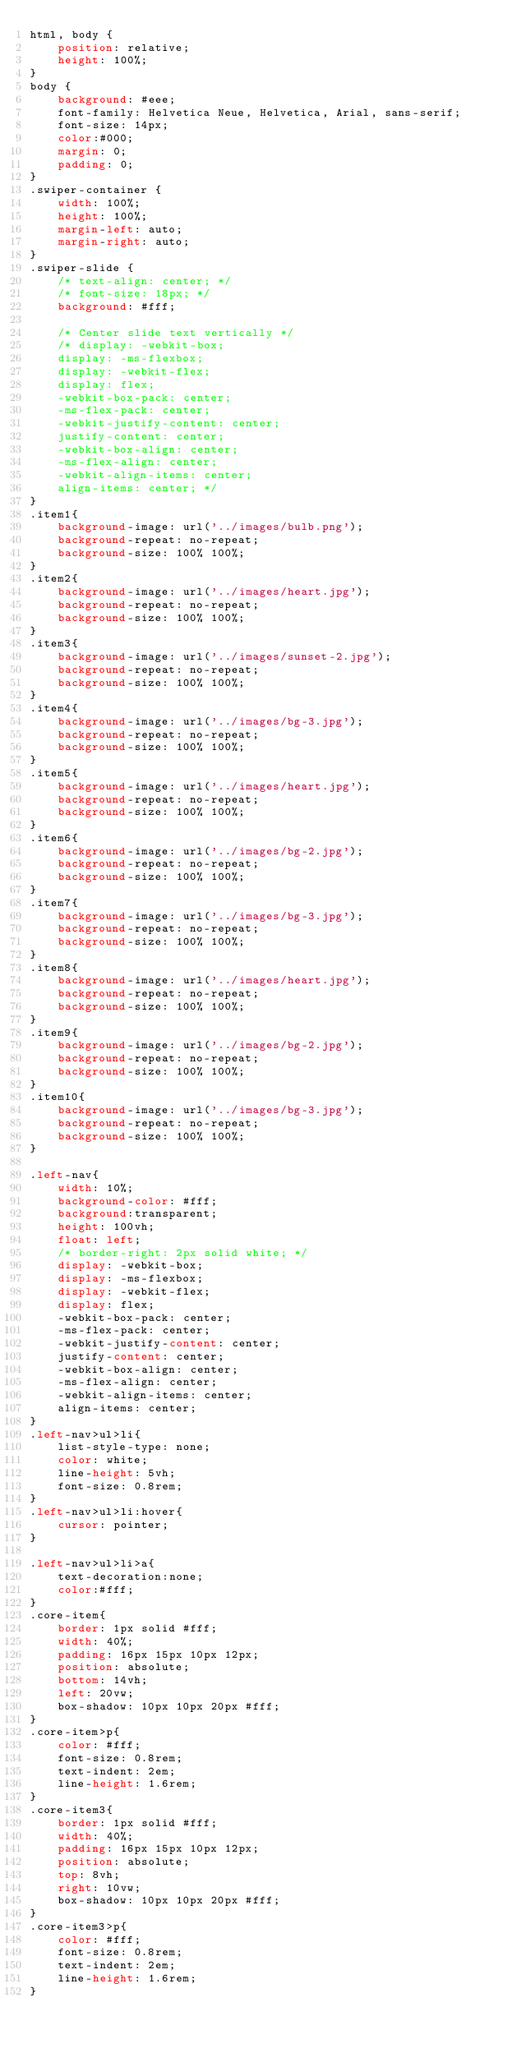Convert code to text. <code><loc_0><loc_0><loc_500><loc_500><_CSS_>html, body {
    position: relative;
    height: 100%;
}
body {
    background: #eee;
    font-family: Helvetica Neue, Helvetica, Arial, sans-serif;
    font-size: 14px;
    color:#000;
    margin: 0;
    padding: 0;
}
.swiper-container {
    width: 100%;
    height: 100%;
    margin-left: auto;
    margin-right: auto;
}
.swiper-slide {
    /* text-align: center; */
    /* font-size: 18px; */
    background: #fff;

    /* Center slide text vertically */
    /* display: -webkit-box;
    display: -ms-flexbox;
    display: -webkit-flex;
    display: flex;
    -webkit-box-pack: center;
    -ms-flex-pack: center;
    -webkit-justify-content: center;
    justify-content: center;
    -webkit-box-align: center;
    -ms-flex-align: center;
    -webkit-align-items: center;
    align-items: center; */
}
.item1{
    background-image: url('../images/bulb.png');
    background-repeat: no-repeat;
    background-size: 100% 100%;
}
.item2{
    background-image: url('../images/heart.jpg');
    background-repeat: no-repeat;
    background-size: 100% 100%;
}
.item3{
    background-image: url('../images/sunset-2.jpg');
    background-repeat: no-repeat;
    background-size: 100% 100%;
}
.item4{
    background-image: url('../images/bg-3.jpg');
    background-repeat: no-repeat;
    background-size: 100% 100%;
}
.item5{
    background-image: url('../images/heart.jpg');
    background-repeat: no-repeat;
    background-size: 100% 100%;
}
.item6{
    background-image: url('../images/bg-2.jpg');
    background-repeat: no-repeat;
    background-size: 100% 100%;
}
.item7{
    background-image: url('../images/bg-3.jpg');
    background-repeat: no-repeat;
    background-size: 100% 100%;
}
.item8{
    background-image: url('../images/heart.jpg');
    background-repeat: no-repeat;
    background-size: 100% 100%;
}
.item9{
    background-image: url('../images/bg-2.jpg');
    background-repeat: no-repeat;
    background-size: 100% 100%;
}
.item10{
    background-image: url('../images/bg-3.jpg');
    background-repeat: no-repeat;
    background-size: 100% 100%;
}

.left-nav{
    width: 10%;
    background-color: #fff;
    background:transparent;
    height: 100vh;
    float: left;
    /* border-right: 2px solid white; */
    display: -webkit-box;
    display: -ms-flexbox;
    display: -webkit-flex;
    display: flex;
    -webkit-box-pack: center;
    -ms-flex-pack: center;
    -webkit-justify-content: center;
    justify-content: center;
    -webkit-box-align: center;
    -ms-flex-align: center;
    -webkit-align-items: center;
    align-items: center;
}
.left-nav>ul>li{
    list-style-type: none;
    color: white;
    line-height: 5vh;
    font-size: 0.8rem;
}
.left-nav>ul>li:hover{
    cursor: pointer;
}

.left-nav>ul>li>a{
    text-decoration:none;
    color:#fff;
}
.core-item{
    border: 1px solid #fff;
    width: 40%;
    padding: 16px 15px 10px 12px;
    position: absolute;
    bottom: 14vh;
    left: 20vw;
    box-shadow: 10px 10px 20px #fff;
}
.core-item>p{
    color: #fff;
    font-size: 0.8rem;
    text-indent: 2em;
    line-height: 1.6rem;
}
.core-item3{
    border: 1px solid #fff;
    width: 40%;
    padding: 16px 15px 10px 12px;
    position: absolute;
    top: 8vh;
    right: 10vw;
    box-shadow: 10px 10px 20px #fff;
}
.core-item3>p{
    color: #fff;
    font-size: 0.8rem;
    text-indent: 2em;
    line-height: 1.6rem;
}</code> 